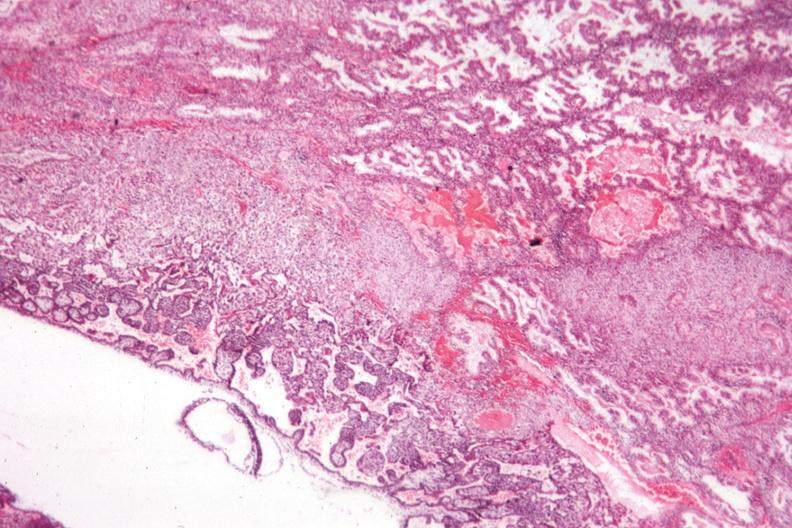s fibrotic lesion present?
Answer the question using a single word or phrase. No 